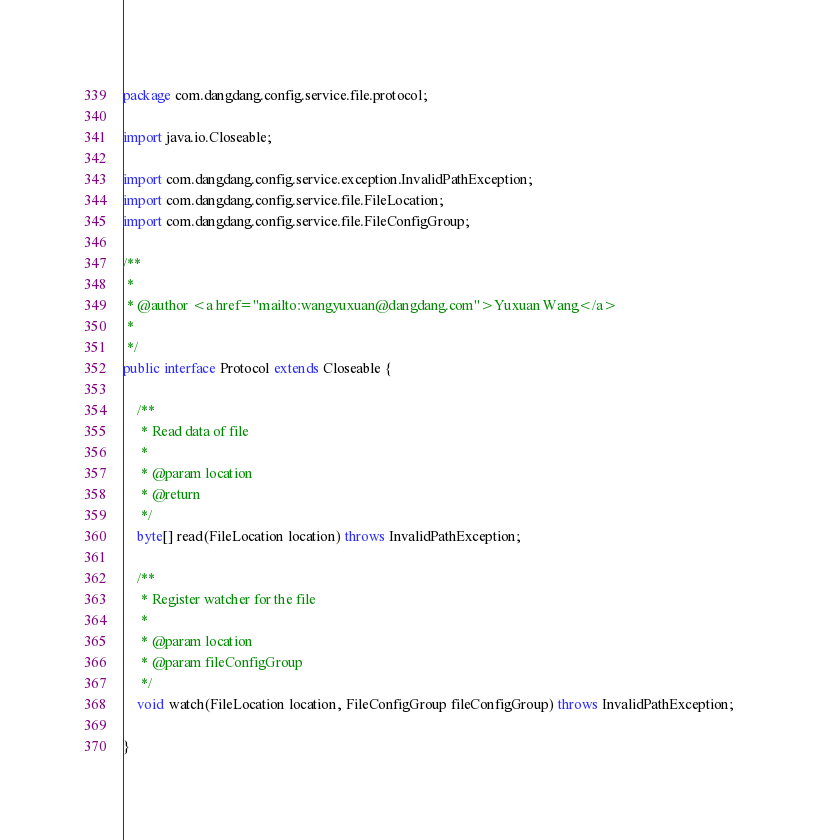Convert code to text. <code><loc_0><loc_0><loc_500><loc_500><_Java_>package com.dangdang.config.service.file.protocol;

import java.io.Closeable;

import com.dangdang.config.service.exception.InvalidPathException;
import com.dangdang.config.service.file.FileLocation;
import com.dangdang.config.service.file.FileConfigGroup;

/**
 * 
 * @author <a href="mailto:wangyuxuan@dangdang.com">Yuxuan Wang</a>
 *
 */
public interface Protocol extends Closeable {

	/**
	 * Read data of file
	 * 
	 * @param location
	 * @return
	 */
	byte[] read(FileLocation location) throws InvalidPathException;

	/**
	 * Register watcher for the file
	 * 
	 * @param location
	 * @param fileConfigGroup
	 */
	void watch(FileLocation location, FileConfigGroup fileConfigGroup) throws InvalidPathException;

}
</code> 